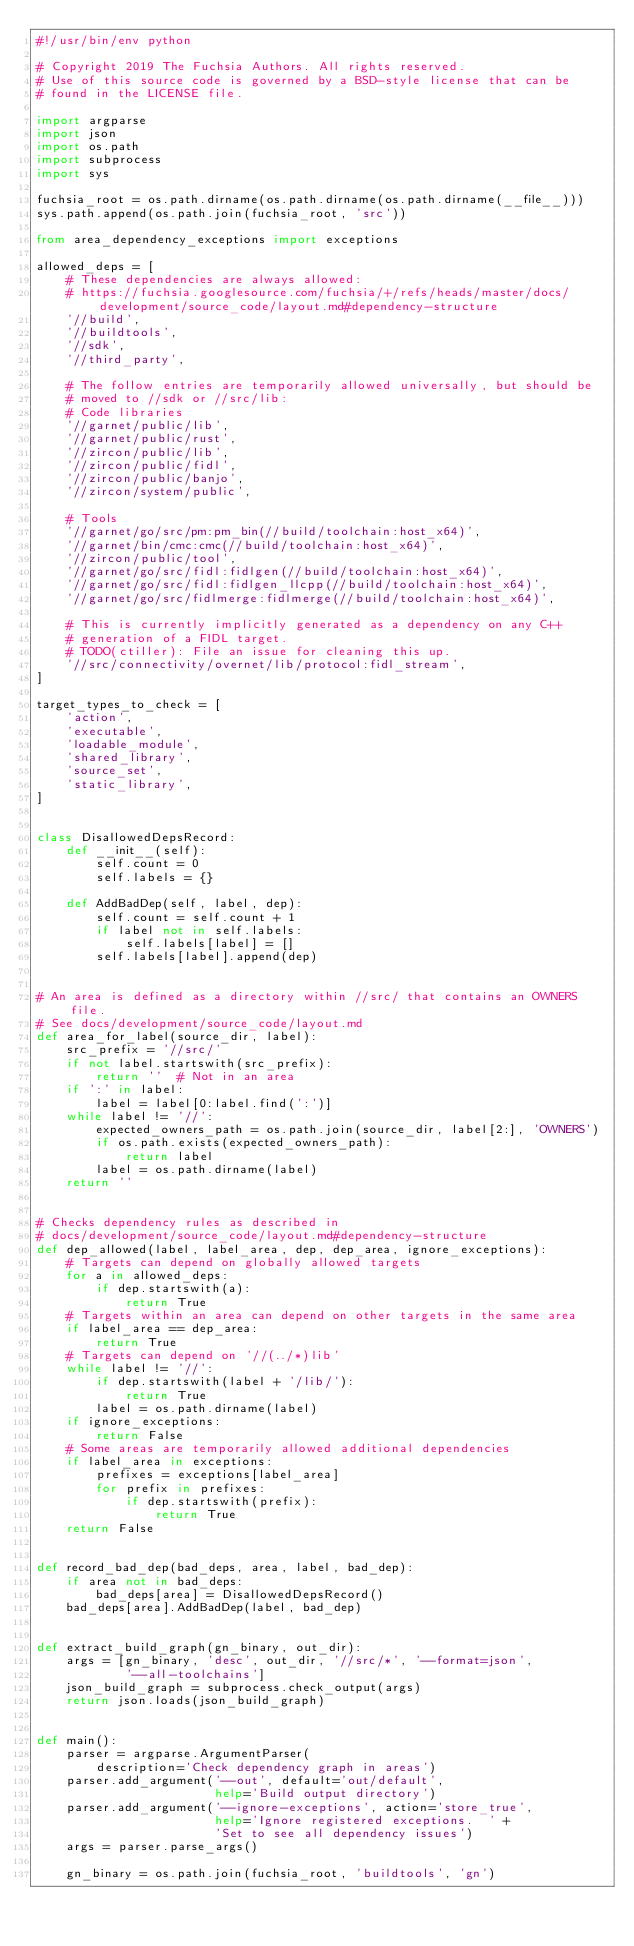<code> <loc_0><loc_0><loc_500><loc_500><_Python_>#!/usr/bin/env python

# Copyright 2019 The Fuchsia Authors. All rights reserved.
# Use of this source code is governed by a BSD-style license that can be
# found in the LICENSE file.

import argparse
import json
import os.path
import subprocess
import sys

fuchsia_root = os.path.dirname(os.path.dirname(os.path.dirname(__file__)))
sys.path.append(os.path.join(fuchsia_root, 'src'))

from area_dependency_exceptions import exceptions

allowed_deps = [
    # These dependencies are always allowed:
    # https://fuchsia.googlesource.com/fuchsia/+/refs/heads/master/docs/development/source_code/layout.md#dependency-structure
    '//build',
    '//buildtools',
    '//sdk',
    '//third_party',

    # The follow entries are temporarily allowed universally, but should be
    # moved to //sdk or //src/lib:
    # Code libraries
    '//garnet/public/lib',
    '//garnet/public/rust',
    '//zircon/public/lib',
    '//zircon/public/fidl',
    '//zircon/public/banjo',
    '//zircon/system/public',

    # Tools
    '//garnet/go/src/pm:pm_bin(//build/toolchain:host_x64)',
    '//garnet/bin/cmc:cmc(//build/toolchain:host_x64)',
    '//zircon/public/tool',
    '//garnet/go/src/fidl:fidlgen(//build/toolchain:host_x64)',
    '//garnet/go/src/fidl:fidlgen_llcpp(//build/toolchain:host_x64)',
    '//garnet/go/src/fidlmerge:fidlmerge(//build/toolchain:host_x64)',

    # This is currently implicitly generated as a dependency on any C++
    # generation of a FIDL target.
    # TODO(ctiller): File an issue for cleaning this up.
    '//src/connectivity/overnet/lib/protocol:fidl_stream',
]

target_types_to_check = [
    'action',
    'executable',
    'loadable_module',
    'shared_library',
    'source_set',
    'static_library',
]


class DisallowedDepsRecord:
    def __init__(self):
        self.count = 0
        self.labels = {}

    def AddBadDep(self, label, dep):
        self.count = self.count + 1
        if label not in self.labels:
            self.labels[label] = []
        self.labels[label].append(dep)


# An area is defined as a directory within //src/ that contains an OWNERS file.
# See docs/development/source_code/layout.md
def area_for_label(source_dir, label):
    src_prefix = '//src/'
    if not label.startswith(src_prefix):
        return ''  # Not in an area
    if ':' in label:
        label = label[0:label.find(':')]
    while label != '//':
        expected_owners_path = os.path.join(source_dir, label[2:], 'OWNERS')
        if os.path.exists(expected_owners_path):
            return label
        label = os.path.dirname(label)
    return ''


# Checks dependency rules as described in
# docs/development/source_code/layout.md#dependency-structure
def dep_allowed(label, label_area, dep, dep_area, ignore_exceptions):
    # Targets can depend on globally allowed targets
    for a in allowed_deps:
        if dep.startswith(a):
            return True
    # Targets within an area can depend on other targets in the same area
    if label_area == dep_area:
        return True
    # Targets can depend on '//(../*)lib'
    while label != '//':
        if dep.startswith(label + '/lib/'):
            return True
        label = os.path.dirname(label)
    if ignore_exceptions:
        return False
    # Some areas are temporarily allowed additional dependencies
    if label_area in exceptions:
        prefixes = exceptions[label_area]
        for prefix in prefixes:
            if dep.startswith(prefix):
                return True
    return False


def record_bad_dep(bad_deps, area, label, bad_dep):
    if area not in bad_deps:
        bad_deps[area] = DisallowedDepsRecord()
    bad_deps[area].AddBadDep(label, bad_dep)


def extract_build_graph(gn_binary, out_dir):
    args = [gn_binary, 'desc', out_dir, '//src/*', '--format=json',
            '--all-toolchains']
    json_build_graph = subprocess.check_output(args)
    return json.loads(json_build_graph)


def main():
    parser = argparse.ArgumentParser(
        description='Check dependency graph in areas')
    parser.add_argument('--out', default='out/default',
                        help='Build output directory')
    parser.add_argument('--ignore-exceptions', action='store_true',
                        help='Ignore registered exceptions.  ' +
                        'Set to see all dependency issues')
    args = parser.parse_args()

    gn_binary = os.path.join(fuchsia_root, 'buildtools', 'gn')</code> 